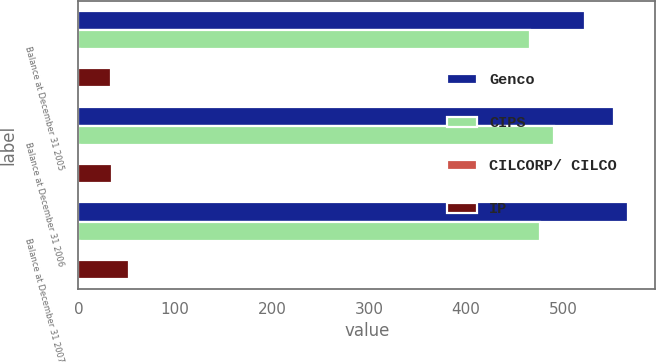Convert chart to OTSL. <chart><loc_0><loc_0><loc_500><loc_500><stacked_bar_chart><ecel><fcel>Balance at December 31 2005<fcel>Balance at December 31 2006<fcel>Balance at December 31 2007<nl><fcel>Genco<fcel>523<fcel>553<fcel>567<nl><fcel>CIPS<fcel>466<fcel>491<fcel>476<nl><fcel>CILCORP/ CILCO<fcel>2<fcel>2<fcel>2<nl><fcel>IP<fcel>34<fcel>35<fcel>52<nl></chart> 